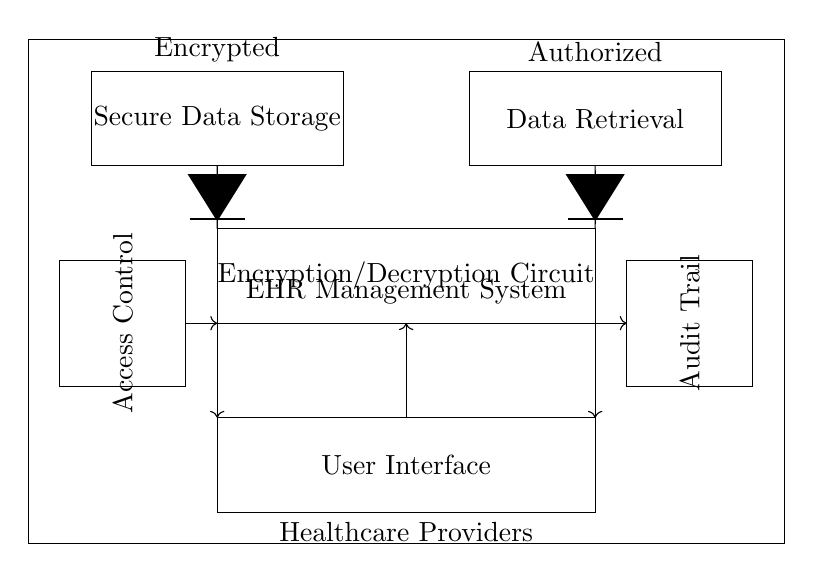What is the main component responsible for data storage? The component labeled "Secure Data Storage" is responsible for data storage in this circuit.
Answer: Secure Data Storage What does the rectangle labeled "Encryption/Decryption Circuit" indicate? This rectangle indicates a function where data is encrypted before storage and decrypted for retrieval, ensuring security.
Answer: Encryption/Decryption Circuit How many user interface components are shown in the circuit? There is one user interface component shown in the circuit diagram.
Answer: One Which part of the circuit is connected to access control? The "Access Control" rectangle is connected to the encryption/decryption circuit and serves to regulate access.
Answer: Access Control What type of data does the "Audit Trail" keep track of? The "Audit Trail" keeps track of all access and changes made to the stored data for security and compliance.
Answer: All access and changes When data is retrieved, what must it be? The data must be authorized according to the "Data Retrieval" part of the circuit.
Answer: Authorized How is data transmitted from the encryption circuit to the user interface? Data is transmitted via arrows indicating the flow from the encryption/decryption circuit to the user interface, ensuring processed data is sent.
Answer: Arrows indicate data flow 